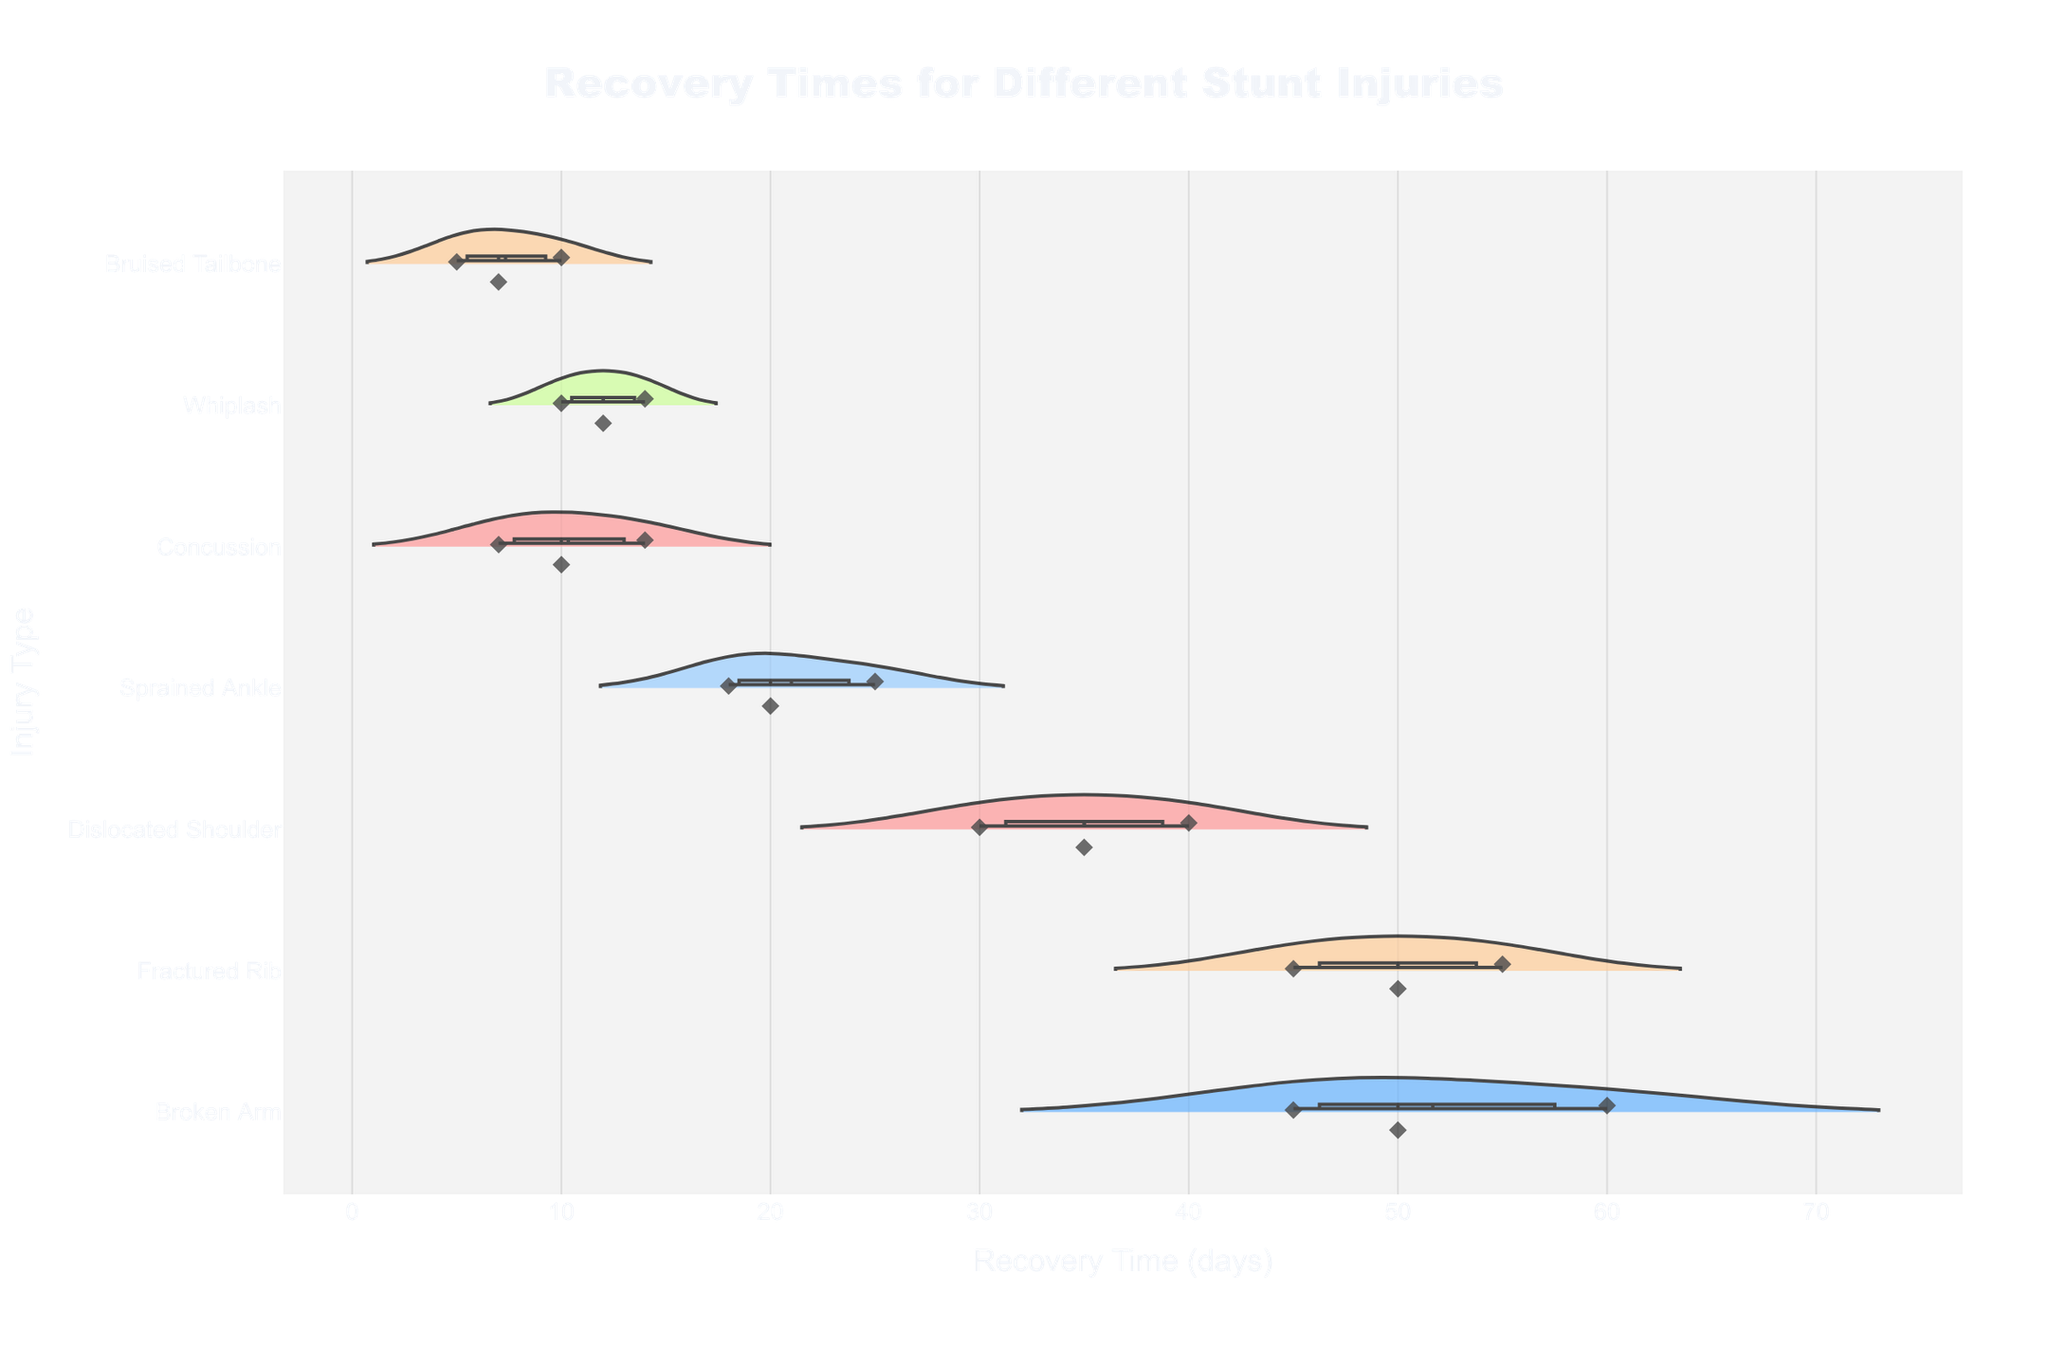What is the title of the figure? The title is usually displayed at the top of the figure. In this case, the title "Recovery Times for Different Stunt Injuries" is explicitly specified within the code comments.
Answer: "Recovery Times for Different Stunt Injuries" How many injury types are shown in the figure? By examining the unique values in the 'Injury Type' column of the provided data, there are seven unique types: Broken Arm, Concussion, Sprained Ankle, Dislocated Shoulder, Fractured Rib, Whiplash, and Bruised Tailbone.
Answer: Seven Which injury has the longest recovery time? By looking at the horizontal axis (Recovery Time in days), we can see that the longest recovery time is 60 days, which corresponds to a Broken Arm.
Answer: Broken Arm Which injury has the shortest recovery time? The shortest recovery time is 5 days, which corresponds to a Bruised Tailbone, as shown on the leftmost part of the horizontal axis.
Answer: Bruised Tailbone What is the mean recovery time for Concussions? The figure includes a mean line for each injury type. By estimating from the figure, the mean recovery time for Concussions appears to be between the data points at 10 and 14 days.
Answer: Approximately 10.3 days What is the range of recovery times for a Sprained Ankle? The range can be determined by finding the smallest and largest data points for Sprained Ankle, which are 18 days and 25 days respectively, making the range 25 - 18 = 7 days.
Answer: 7 days Which injury type has the most data points? By counting the number of points within each violin plot, Broken Arm has the most data points with three occurrences of recovery times (45, 50, 60 days).
Answer: Broken Arm Is there an injury type with no outliers? By observing the presence of points outside the main distribution, it appears that Whiplash has no outliers, as all points lie within the central distribution.
Answer: Whiplash How does the distribution of recovery times for Fractured Ribs compare to Dislocated Shoulders? Fractured Ribs have a typically wider spread with recovery times ranging from 45 to 55 days, while Dislocated Shoulders range from 30 to 40 days. Thus, Fractured Ribs have a larger range and more variability.
Answer: Fractured Ribs show wider spread and more variability Which injury type shows the most symmetry in its recovery time distribution? By visually examining the violin plots, the distribution for Bruised Tailbone is the most symmetric, with evenly distributed points at 5, 7, and 10 days.
Answer: Bruised Tailbone 